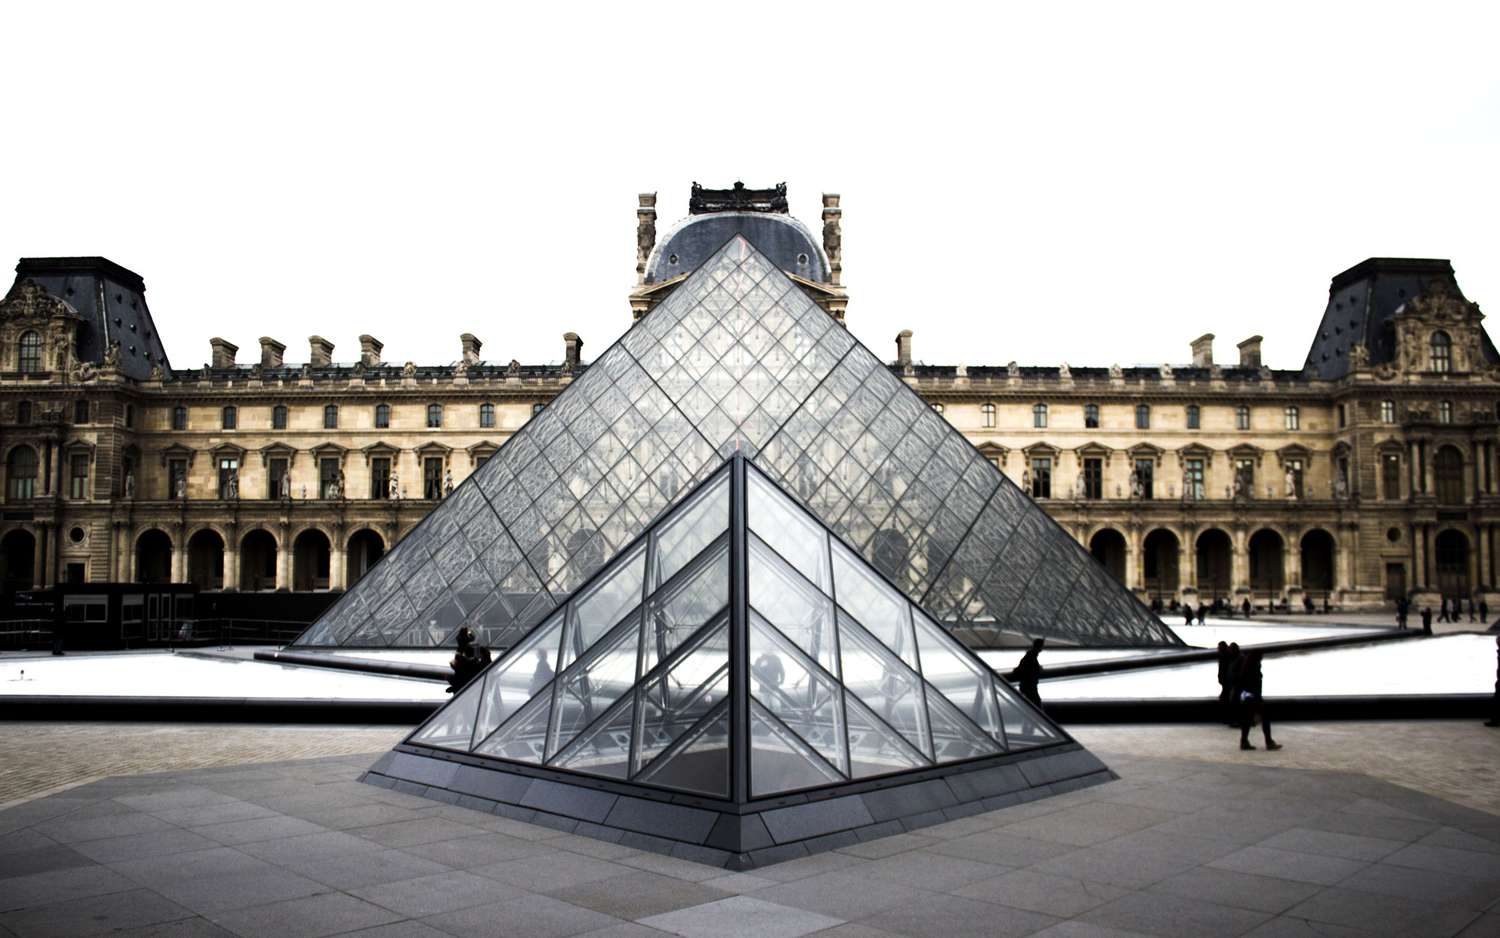How might a rainy day affect the visual appeal of the Louvre pyramid? A rainy day at the Louvre pyramid would introduce a new dimension to its visual appeal. The glass surfaces would glisten with raindrops, creating a shimmering effect that enhances the structure's modern elegance. The play of light on the wet glass would produce a myriad of reflections and refractions, transforming the pyramid into a living, breathing entity that interacts with the elements in real-time. The overcast sky would likely deepen the contrast between the sleek, shining surfaces of the pyramid and the historic, stately architecture of the Louvre Palace. Visitors might see the reflections of the palace distorted in intriguing ways on the puddles forming around the pyramid. Such a scene would offer a poetic and almost melancholic charm, evoking deep contemplation and appreciation for both the old and the new.  Describe the scene at the Louvre pyramid during a bustling summer day. On a bustling summer day, the scene at the Louvre pyramid is vibrant and full of energy. The sky is clear, the sun shines brightly, casting sharp shadows and highlighting the brilliance of the glass and metal construction. Tourists from around the world fill the courtyard, snapping photos, chatting excitedly, and queuing to enter the museum. The sound of laughter and various languages merge into a lively symphony, creating an atmosphere of anticipation and joy.

Street performers and vendors add to the bustle, offering souvenirs, snacks, and impromptu performances that capture the attention of passersby. The central pool of water sparkles under the sun, providing a refreshing sight amid the summer heat. Children play around the edges, their laughter ringing out while adults take a moment to rest on the benches, enjoying the picturesque surroundings.

The historic grandeur of the Louvre Palace stands tall and proud, its imposing structure a perfect backdrop to the buzzing activity. Despite the crowds, there’s a sense of shared wonderment, as everyone present is drawn to the creative and historical significance of the site. This fusion of art, history, and contemporary life makes the Louvre pyramid not just a monument, but a living, breathing part of Parisian culture, especially during the exuberant summer months. 